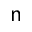<formula> <loc_0><loc_0><loc_500><loc_500>n</formula> 